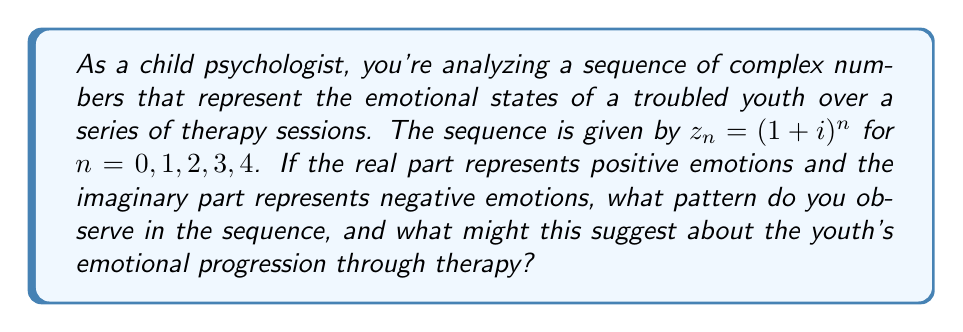Can you solve this math problem? Let's calculate the first five terms of the sequence $z_n = (1+i)^n$ for $n = 0, 1, 2, 3, 4$:

1) For $n = 0$: $z_0 = (1+i)^0 = 1$

2) For $n = 1$: $z_1 = (1+i)^1 = 1+i$

3) For $n = 2$: $z_2 = (1+i)^2 = (1+i)(1+i) = 1+2i-1 = 2i$

4) For $n = 3$: $z_3 = (1+i)^3 = (1+i)(2i) = 2i-2 = -2+2i$

5) For $n = 4$: $z_4 = (1+i)^4 = (1+i)(-2+2i) = -2+2i-2i-2 = -4$

Now, let's analyze the pattern:

$$z_0 = 1$$
$$z_1 = 1+i$$
$$z_2 = 2i$$
$$z_3 = -2+2i$$
$$z_4 = -4$$

We can observe that:
- The magnitude (absolute value) of the numbers is increasing: $|z_0| = 1$, $|z_1| = \sqrt{2}$, $|z_2| = 2$, $|z_3| = 2\sqrt{2}$, $|z_4| = 4$
- The arguments (angles) of the complex numbers are rotating counterclockwise by 45° each step
- The real part oscillates between positive and negative, while the imaginary part peaks at $n=2$ and $n=3$

In terms of emotional interpretation:
1. The increasing magnitude suggests intensifying emotions overall.
2. The rotation indicates a cyclical nature to the emotional states.
3. The oscillation between positive and negative real parts suggests mood swings.
4. The peak in the imaginary part (negative emotions) in the middle of the sequence followed by a decrease might indicate a breakthrough in therapy.

This pattern could suggest that the youth is experiencing more intense emotions as therapy progresses, with alternating positive and negative states. The peak in negative emotions followed by a decrease might indicate that the youth is working through difficult issues and starting to show improvement.
Answer: The observed pattern shows increasing emotional intensity, cyclical mood changes, and a peak in negative emotions followed by a decrease. This suggests the youth may be experiencing more intense emotions during therapy, working through difficult issues, and potentially showing signs of improvement towards the end of the observed sessions. 